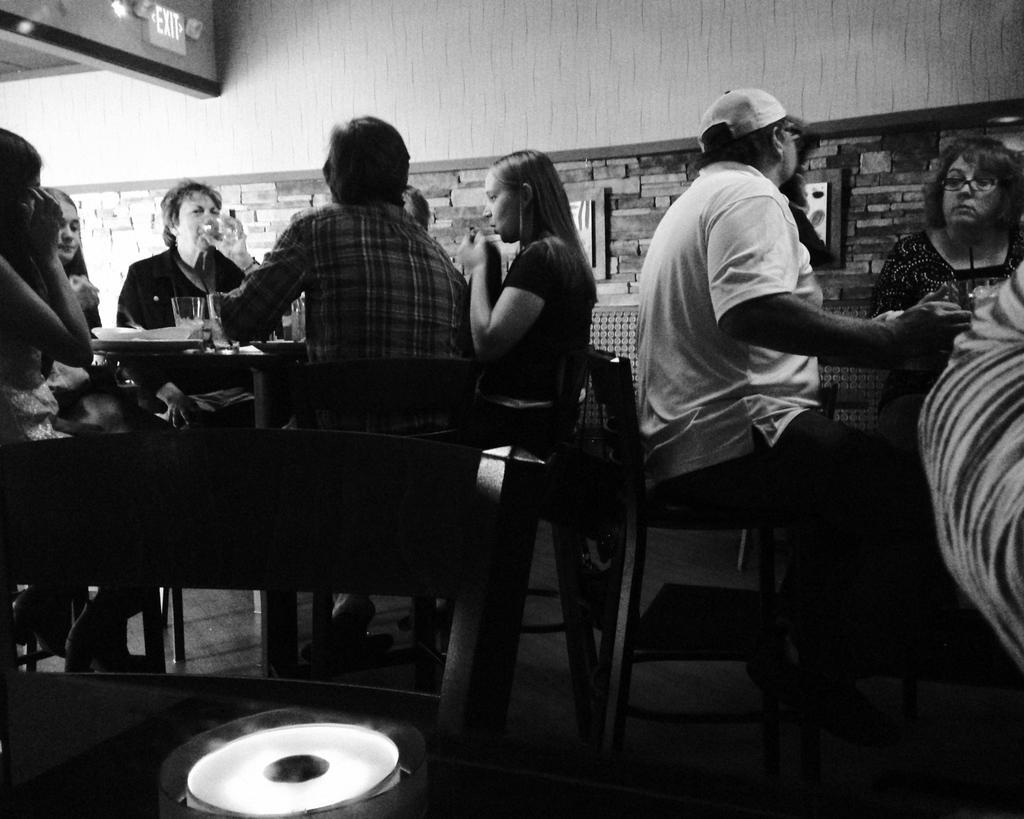Can you describe this image briefly? This picture shows a group of people seated on the chairs and we see man holding a glass and drinking 